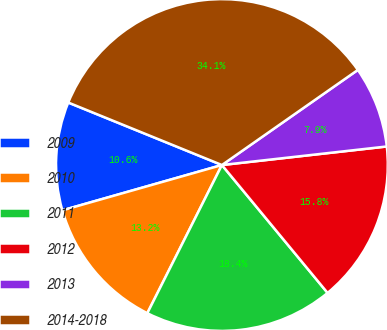Convert chart. <chart><loc_0><loc_0><loc_500><loc_500><pie_chart><fcel>2009<fcel>2010<fcel>2011<fcel>2012<fcel>2013<fcel>2014-2018<nl><fcel>10.55%<fcel>13.17%<fcel>18.41%<fcel>15.79%<fcel>7.93%<fcel>34.13%<nl></chart> 